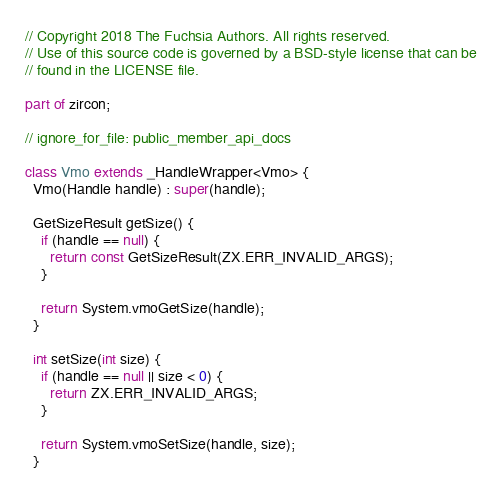<code> <loc_0><loc_0><loc_500><loc_500><_Dart_>// Copyright 2018 The Fuchsia Authors. All rights reserved.
// Use of this source code is governed by a BSD-style license that can be
// found in the LICENSE file.

part of zircon;

// ignore_for_file: public_member_api_docs

class Vmo extends _HandleWrapper<Vmo> {
  Vmo(Handle handle) : super(handle);

  GetSizeResult getSize() {
    if (handle == null) {
      return const GetSizeResult(ZX.ERR_INVALID_ARGS);
    }

    return System.vmoGetSize(handle);
  }

  int setSize(int size) {
    if (handle == null || size < 0) {
      return ZX.ERR_INVALID_ARGS;
    }

    return System.vmoSetSize(handle, size);
  }
</code> 